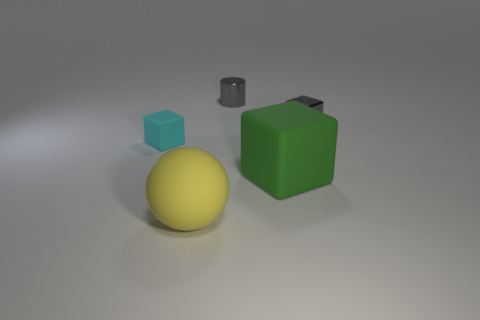Is there any object that stands out because of its color? Yes, the cyan matte block stands out with its vibrant hue, contrasting sharply against the more subdued colors present in the scene. 